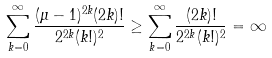<formula> <loc_0><loc_0><loc_500><loc_500>\sum _ { k = 0 } ^ { \infty } \frac { ( \mu - 1 ) ^ { 2 k } ( 2 k ) ! } { 2 ^ { 2 k } ( k ! ) ^ { 2 } } \geq \sum _ { k = 0 } ^ { \infty } \frac { ( 2 k ) ! } { 2 ^ { 2 k } ( k ! ) ^ { 2 } } = \infty</formula> 